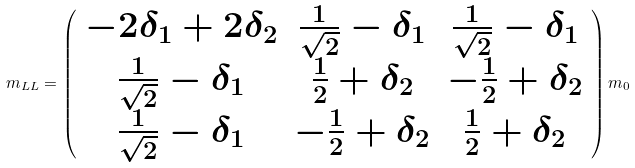<formula> <loc_0><loc_0><loc_500><loc_500>m _ { L L } = \left ( \begin{array} { c c c } - 2 \delta _ { 1 } + 2 \delta _ { 2 } & \frac { 1 } { \sqrt { 2 } } - \delta _ { 1 } & \frac { 1 } { \sqrt { 2 } } - \delta _ { 1 } \\ \frac { 1 } { \sqrt { 2 } } - \delta _ { 1 } & \frac { 1 } { 2 } + \delta _ { 2 } & - \frac { 1 } { 2 } + \delta _ { 2 } \\ \frac { 1 } { \sqrt { 2 } } - \delta _ { 1 } & - \frac { 1 } { 2 } + \delta _ { 2 } & \frac { 1 } { 2 } + \delta _ { 2 } \end{array} \right ) m _ { 0 }</formula> 